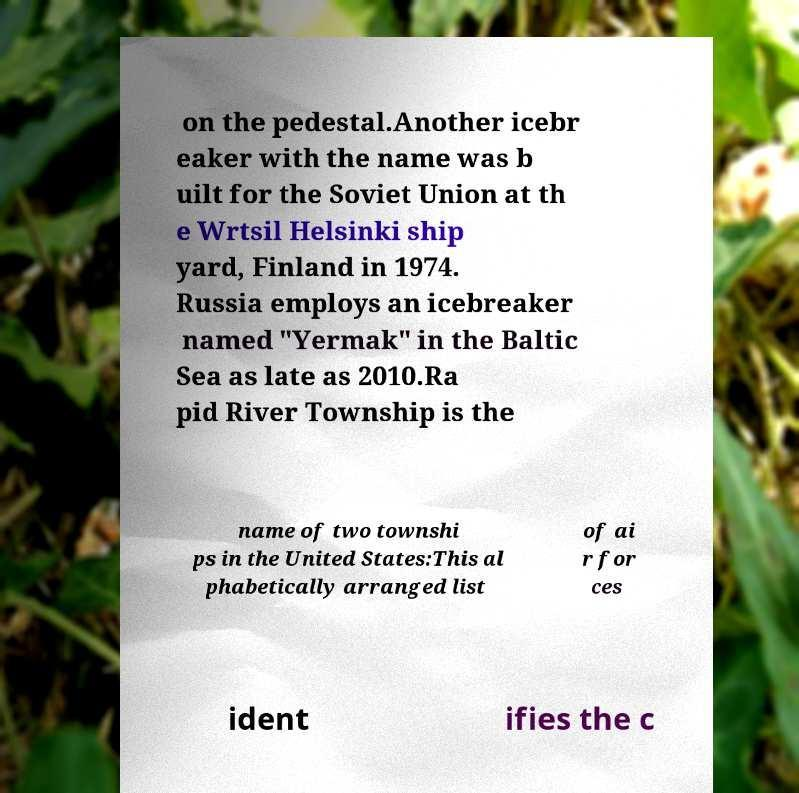I need the written content from this picture converted into text. Can you do that? on the pedestal.Another icebr eaker with the name was b uilt for the Soviet Union at th e Wrtsil Helsinki ship yard, Finland in 1974. Russia employs an icebreaker named "Yermak" in the Baltic Sea as late as 2010.Ra pid River Township is the name of two townshi ps in the United States:This al phabetically arranged list of ai r for ces ident ifies the c 